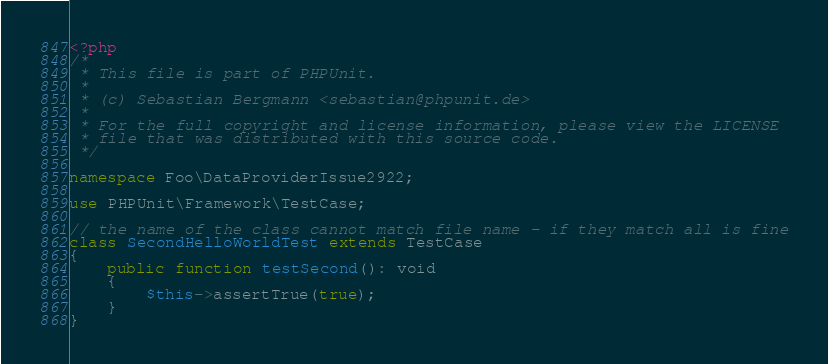<code> <loc_0><loc_0><loc_500><loc_500><_PHP_><?php
/*
 * This file is part of PHPUnit.
 *
 * (c) Sebastian Bergmann <sebastian@phpunit.de>
 *
 * For the full copyright and license information, please view the LICENSE
 * file that was distributed with this source code.
 */

namespace Foo\DataProviderIssue2922;

use PHPUnit\Framework\TestCase;

// the name of the class cannot match file name - if they match all is fine
class SecondHelloWorldTest extends TestCase
{
    public function testSecond(): void
    {
        $this->assertTrue(true);
    }
}
</code> 